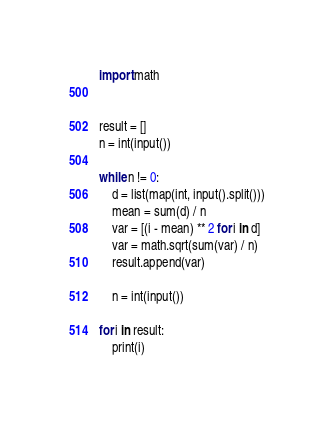Convert code to text. <code><loc_0><loc_0><loc_500><loc_500><_Python_>import math


result = []
n = int(input())

while n != 0:
    d = list(map(int, input().split()))
    mean = sum(d) / n
    var = [(i - mean) ** 2 for i in d]
    var = math.sqrt(sum(var) / n)
    result.append(var)
    
    n = int(input())

for i in result:
    print(i)
</code> 